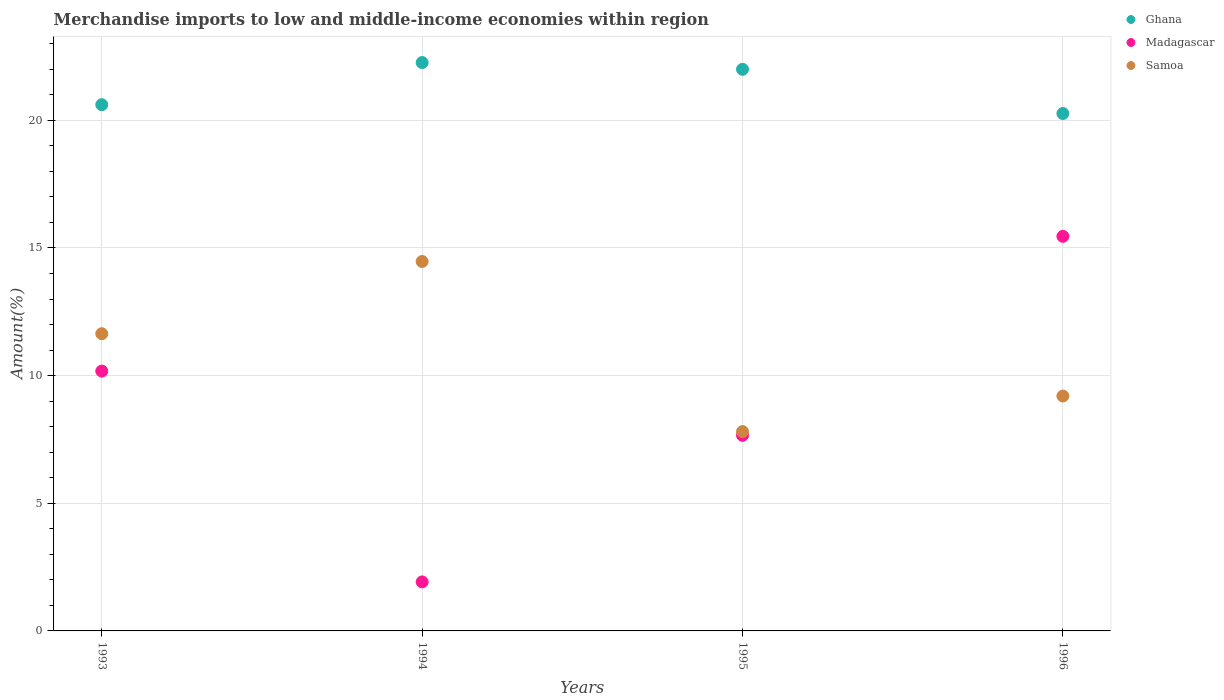What is the percentage of amount earned from merchandise imports in Madagascar in 1995?
Provide a succinct answer. 7.66. Across all years, what is the maximum percentage of amount earned from merchandise imports in Samoa?
Make the answer very short. 14.47. Across all years, what is the minimum percentage of amount earned from merchandise imports in Ghana?
Ensure brevity in your answer.  20.27. In which year was the percentage of amount earned from merchandise imports in Samoa minimum?
Keep it short and to the point. 1995. What is the total percentage of amount earned from merchandise imports in Samoa in the graph?
Keep it short and to the point. 43.12. What is the difference between the percentage of amount earned from merchandise imports in Samoa in 1993 and that in 1996?
Keep it short and to the point. 2.44. What is the difference between the percentage of amount earned from merchandise imports in Ghana in 1994 and the percentage of amount earned from merchandise imports in Madagascar in 1996?
Give a very brief answer. 6.81. What is the average percentage of amount earned from merchandise imports in Samoa per year?
Make the answer very short. 10.78. In the year 1993, what is the difference between the percentage of amount earned from merchandise imports in Madagascar and percentage of amount earned from merchandise imports in Samoa?
Offer a terse response. -1.46. What is the ratio of the percentage of amount earned from merchandise imports in Samoa in 1994 to that in 1995?
Provide a short and direct response. 1.85. What is the difference between the highest and the second highest percentage of amount earned from merchandise imports in Samoa?
Offer a terse response. 2.83. What is the difference between the highest and the lowest percentage of amount earned from merchandise imports in Samoa?
Provide a succinct answer. 6.66. In how many years, is the percentage of amount earned from merchandise imports in Ghana greater than the average percentage of amount earned from merchandise imports in Ghana taken over all years?
Offer a terse response. 2. Is the sum of the percentage of amount earned from merchandise imports in Madagascar in 1994 and 1995 greater than the maximum percentage of amount earned from merchandise imports in Ghana across all years?
Your answer should be compact. No. Does the percentage of amount earned from merchandise imports in Ghana monotonically increase over the years?
Make the answer very short. No. Is the percentage of amount earned from merchandise imports in Ghana strictly less than the percentage of amount earned from merchandise imports in Samoa over the years?
Offer a very short reply. No. How many dotlines are there?
Your answer should be very brief. 3. How many years are there in the graph?
Your answer should be compact. 4. Are the values on the major ticks of Y-axis written in scientific E-notation?
Give a very brief answer. No. Does the graph contain any zero values?
Provide a short and direct response. No. Does the graph contain grids?
Your response must be concise. Yes. Where does the legend appear in the graph?
Your answer should be very brief. Top right. What is the title of the graph?
Provide a short and direct response. Merchandise imports to low and middle-income economies within region. What is the label or title of the Y-axis?
Provide a succinct answer. Amount(%). What is the Amount(%) in Ghana in 1993?
Provide a succinct answer. 20.61. What is the Amount(%) in Madagascar in 1993?
Give a very brief answer. 10.18. What is the Amount(%) in Samoa in 1993?
Your answer should be compact. 11.64. What is the Amount(%) in Ghana in 1994?
Keep it short and to the point. 22.26. What is the Amount(%) of Madagascar in 1994?
Your answer should be very brief. 1.92. What is the Amount(%) in Samoa in 1994?
Your answer should be very brief. 14.47. What is the Amount(%) in Ghana in 1995?
Ensure brevity in your answer.  22. What is the Amount(%) in Madagascar in 1995?
Ensure brevity in your answer.  7.66. What is the Amount(%) of Samoa in 1995?
Offer a very short reply. 7.81. What is the Amount(%) of Ghana in 1996?
Make the answer very short. 20.27. What is the Amount(%) in Madagascar in 1996?
Keep it short and to the point. 15.46. What is the Amount(%) in Samoa in 1996?
Keep it short and to the point. 9.2. Across all years, what is the maximum Amount(%) in Ghana?
Ensure brevity in your answer.  22.26. Across all years, what is the maximum Amount(%) of Madagascar?
Offer a very short reply. 15.46. Across all years, what is the maximum Amount(%) of Samoa?
Ensure brevity in your answer.  14.47. Across all years, what is the minimum Amount(%) of Ghana?
Provide a short and direct response. 20.27. Across all years, what is the minimum Amount(%) in Madagascar?
Offer a terse response. 1.92. Across all years, what is the minimum Amount(%) of Samoa?
Provide a succinct answer. 7.81. What is the total Amount(%) in Ghana in the graph?
Ensure brevity in your answer.  85.14. What is the total Amount(%) of Madagascar in the graph?
Offer a terse response. 35.21. What is the total Amount(%) of Samoa in the graph?
Offer a terse response. 43.12. What is the difference between the Amount(%) of Ghana in 1993 and that in 1994?
Offer a very short reply. -1.65. What is the difference between the Amount(%) in Madagascar in 1993 and that in 1994?
Ensure brevity in your answer.  8.26. What is the difference between the Amount(%) of Samoa in 1993 and that in 1994?
Offer a very short reply. -2.83. What is the difference between the Amount(%) of Ghana in 1993 and that in 1995?
Offer a very short reply. -1.39. What is the difference between the Amount(%) in Madagascar in 1993 and that in 1995?
Offer a very short reply. 2.52. What is the difference between the Amount(%) of Samoa in 1993 and that in 1995?
Offer a terse response. 3.83. What is the difference between the Amount(%) of Ghana in 1993 and that in 1996?
Your answer should be compact. 0.35. What is the difference between the Amount(%) of Madagascar in 1993 and that in 1996?
Offer a terse response. -5.28. What is the difference between the Amount(%) in Samoa in 1993 and that in 1996?
Provide a succinct answer. 2.44. What is the difference between the Amount(%) in Ghana in 1994 and that in 1995?
Offer a very short reply. 0.26. What is the difference between the Amount(%) in Madagascar in 1994 and that in 1995?
Make the answer very short. -5.74. What is the difference between the Amount(%) of Samoa in 1994 and that in 1995?
Your answer should be very brief. 6.66. What is the difference between the Amount(%) in Ghana in 1994 and that in 1996?
Your answer should be very brief. 2. What is the difference between the Amount(%) in Madagascar in 1994 and that in 1996?
Your answer should be very brief. -13.54. What is the difference between the Amount(%) of Samoa in 1994 and that in 1996?
Give a very brief answer. 5.27. What is the difference between the Amount(%) of Ghana in 1995 and that in 1996?
Your response must be concise. 1.73. What is the difference between the Amount(%) of Madagascar in 1995 and that in 1996?
Your answer should be compact. -7.8. What is the difference between the Amount(%) in Samoa in 1995 and that in 1996?
Offer a very short reply. -1.39. What is the difference between the Amount(%) in Ghana in 1993 and the Amount(%) in Madagascar in 1994?
Your response must be concise. 18.69. What is the difference between the Amount(%) in Ghana in 1993 and the Amount(%) in Samoa in 1994?
Give a very brief answer. 6.14. What is the difference between the Amount(%) of Madagascar in 1993 and the Amount(%) of Samoa in 1994?
Provide a short and direct response. -4.29. What is the difference between the Amount(%) of Ghana in 1993 and the Amount(%) of Madagascar in 1995?
Ensure brevity in your answer.  12.95. What is the difference between the Amount(%) of Ghana in 1993 and the Amount(%) of Samoa in 1995?
Keep it short and to the point. 12.8. What is the difference between the Amount(%) of Madagascar in 1993 and the Amount(%) of Samoa in 1995?
Ensure brevity in your answer.  2.37. What is the difference between the Amount(%) of Ghana in 1993 and the Amount(%) of Madagascar in 1996?
Your answer should be compact. 5.16. What is the difference between the Amount(%) of Ghana in 1993 and the Amount(%) of Samoa in 1996?
Your response must be concise. 11.41. What is the difference between the Amount(%) of Madagascar in 1993 and the Amount(%) of Samoa in 1996?
Ensure brevity in your answer.  0.98. What is the difference between the Amount(%) of Ghana in 1994 and the Amount(%) of Madagascar in 1995?
Provide a short and direct response. 14.6. What is the difference between the Amount(%) in Ghana in 1994 and the Amount(%) in Samoa in 1995?
Ensure brevity in your answer.  14.46. What is the difference between the Amount(%) of Madagascar in 1994 and the Amount(%) of Samoa in 1995?
Provide a short and direct response. -5.89. What is the difference between the Amount(%) in Ghana in 1994 and the Amount(%) in Madagascar in 1996?
Give a very brief answer. 6.81. What is the difference between the Amount(%) of Ghana in 1994 and the Amount(%) of Samoa in 1996?
Keep it short and to the point. 13.06. What is the difference between the Amount(%) of Madagascar in 1994 and the Amount(%) of Samoa in 1996?
Ensure brevity in your answer.  -7.28. What is the difference between the Amount(%) of Ghana in 1995 and the Amount(%) of Madagascar in 1996?
Offer a terse response. 6.54. What is the difference between the Amount(%) of Ghana in 1995 and the Amount(%) of Samoa in 1996?
Offer a terse response. 12.8. What is the difference between the Amount(%) in Madagascar in 1995 and the Amount(%) in Samoa in 1996?
Offer a terse response. -1.54. What is the average Amount(%) of Ghana per year?
Keep it short and to the point. 21.29. What is the average Amount(%) of Madagascar per year?
Your answer should be very brief. 8.8. What is the average Amount(%) of Samoa per year?
Provide a succinct answer. 10.78. In the year 1993, what is the difference between the Amount(%) in Ghana and Amount(%) in Madagascar?
Offer a very short reply. 10.44. In the year 1993, what is the difference between the Amount(%) of Ghana and Amount(%) of Samoa?
Make the answer very short. 8.97. In the year 1993, what is the difference between the Amount(%) of Madagascar and Amount(%) of Samoa?
Your answer should be very brief. -1.46. In the year 1994, what is the difference between the Amount(%) of Ghana and Amount(%) of Madagascar?
Your answer should be compact. 20.34. In the year 1994, what is the difference between the Amount(%) in Ghana and Amount(%) in Samoa?
Ensure brevity in your answer.  7.79. In the year 1994, what is the difference between the Amount(%) in Madagascar and Amount(%) in Samoa?
Make the answer very short. -12.55. In the year 1995, what is the difference between the Amount(%) in Ghana and Amount(%) in Madagascar?
Offer a very short reply. 14.34. In the year 1995, what is the difference between the Amount(%) of Ghana and Amount(%) of Samoa?
Provide a succinct answer. 14.19. In the year 1995, what is the difference between the Amount(%) in Madagascar and Amount(%) in Samoa?
Offer a very short reply. -0.15. In the year 1996, what is the difference between the Amount(%) in Ghana and Amount(%) in Madagascar?
Ensure brevity in your answer.  4.81. In the year 1996, what is the difference between the Amount(%) of Ghana and Amount(%) of Samoa?
Offer a very short reply. 11.07. In the year 1996, what is the difference between the Amount(%) of Madagascar and Amount(%) of Samoa?
Give a very brief answer. 6.26. What is the ratio of the Amount(%) of Ghana in 1993 to that in 1994?
Provide a short and direct response. 0.93. What is the ratio of the Amount(%) in Madagascar in 1993 to that in 1994?
Provide a succinct answer. 5.3. What is the ratio of the Amount(%) of Samoa in 1993 to that in 1994?
Your answer should be compact. 0.8. What is the ratio of the Amount(%) in Ghana in 1993 to that in 1995?
Your answer should be compact. 0.94. What is the ratio of the Amount(%) of Madagascar in 1993 to that in 1995?
Ensure brevity in your answer.  1.33. What is the ratio of the Amount(%) of Samoa in 1993 to that in 1995?
Keep it short and to the point. 1.49. What is the ratio of the Amount(%) of Ghana in 1993 to that in 1996?
Offer a terse response. 1.02. What is the ratio of the Amount(%) in Madagascar in 1993 to that in 1996?
Offer a very short reply. 0.66. What is the ratio of the Amount(%) in Samoa in 1993 to that in 1996?
Your answer should be very brief. 1.27. What is the ratio of the Amount(%) in Ghana in 1994 to that in 1995?
Provide a short and direct response. 1.01. What is the ratio of the Amount(%) in Madagascar in 1994 to that in 1995?
Offer a very short reply. 0.25. What is the ratio of the Amount(%) in Samoa in 1994 to that in 1995?
Your response must be concise. 1.85. What is the ratio of the Amount(%) of Ghana in 1994 to that in 1996?
Offer a very short reply. 1.1. What is the ratio of the Amount(%) in Madagascar in 1994 to that in 1996?
Give a very brief answer. 0.12. What is the ratio of the Amount(%) in Samoa in 1994 to that in 1996?
Your answer should be compact. 1.57. What is the ratio of the Amount(%) in Ghana in 1995 to that in 1996?
Your answer should be very brief. 1.09. What is the ratio of the Amount(%) in Madagascar in 1995 to that in 1996?
Your answer should be compact. 0.5. What is the ratio of the Amount(%) in Samoa in 1995 to that in 1996?
Provide a short and direct response. 0.85. What is the difference between the highest and the second highest Amount(%) in Ghana?
Make the answer very short. 0.26. What is the difference between the highest and the second highest Amount(%) in Madagascar?
Offer a very short reply. 5.28. What is the difference between the highest and the second highest Amount(%) in Samoa?
Offer a terse response. 2.83. What is the difference between the highest and the lowest Amount(%) of Ghana?
Offer a terse response. 2. What is the difference between the highest and the lowest Amount(%) in Madagascar?
Your response must be concise. 13.54. What is the difference between the highest and the lowest Amount(%) of Samoa?
Your answer should be compact. 6.66. 